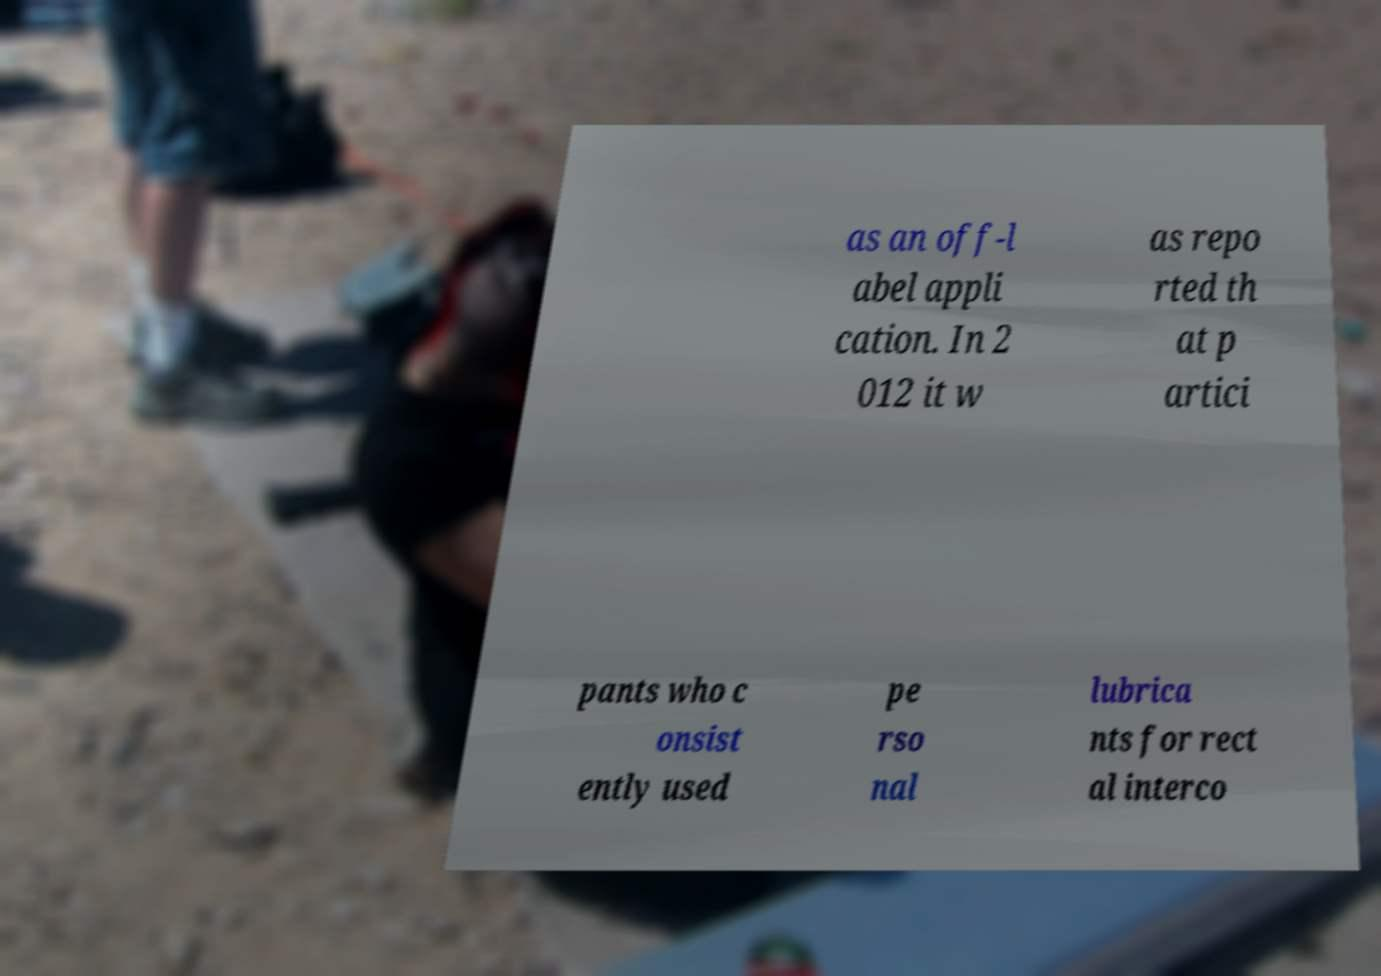I need the written content from this picture converted into text. Can you do that? as an off-l abel appli cation. In 2 012 it w as repo rted th at p artici pants who c onsist ently used pe rso nal lubrica nts for rect al interco 